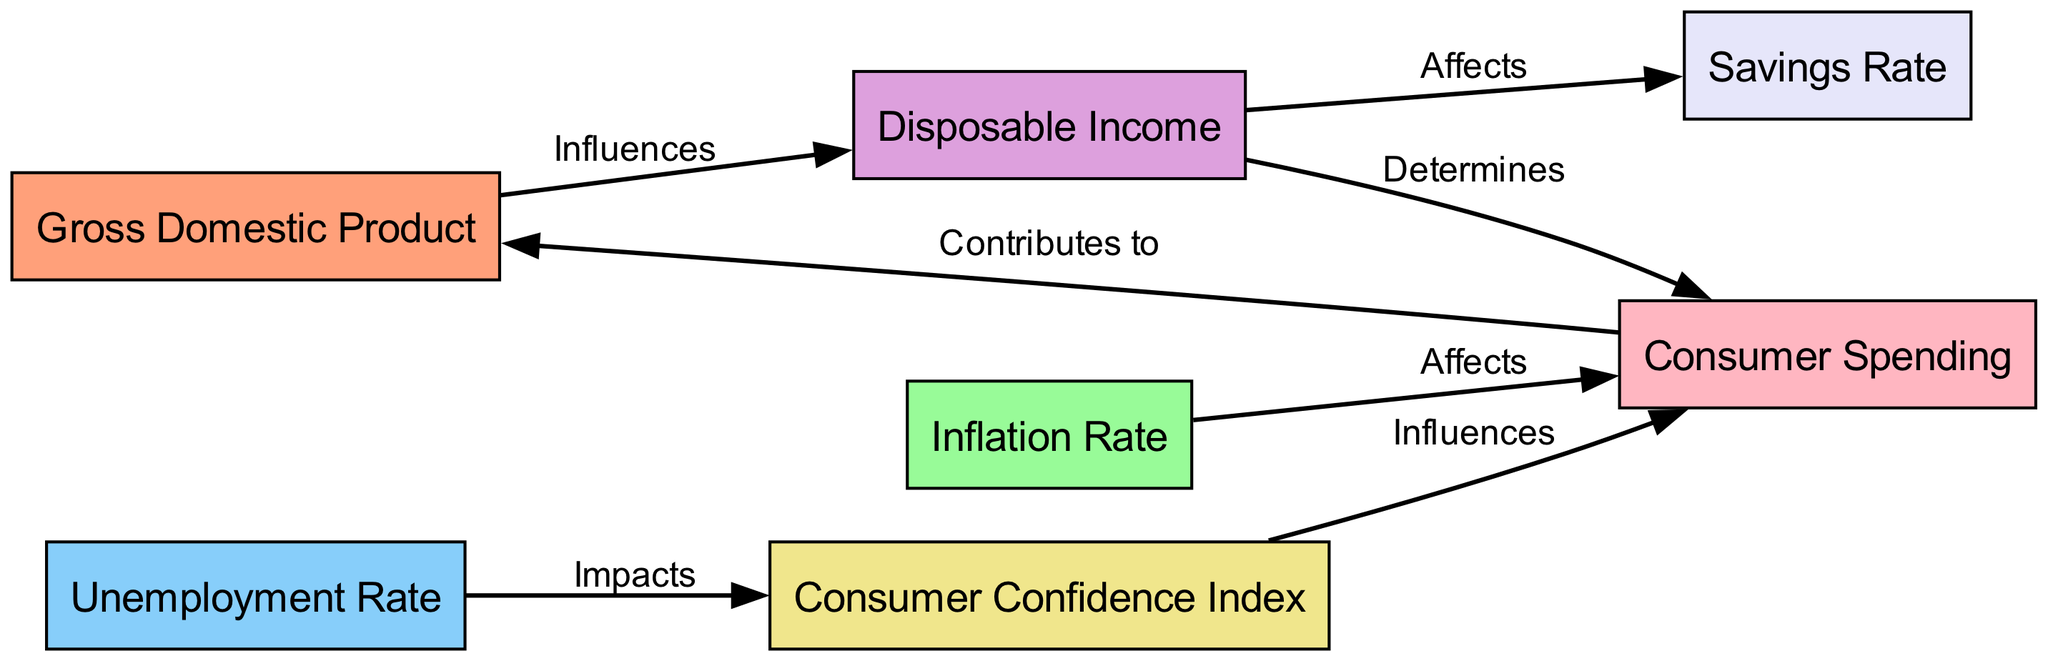What are the nodes represented in the diagram? The nodes in the diagram represent key economic indicators and consumer behavior concepts: Gross Domestic Product, Inflation Rate, Unemployment Rate, Disposable Income, Consumer Confidence Index, Consumer Spending, and Savings Rate.
Answer: Gross Domestic Product, Inflation Rate, Unemployment Rate, Disposable Income, Consumer Confidence Index, Consumer Spending, Savings Rate How many edges are there in total? Counting all the directional connections or edges shown in the diagram, there are a total of 7 edges that illustrate the relationships between the nodes.
Answer: 7 What influences Disposable Income? In the diagram, Disposable Income is influenced by Gross Domestic Product, as indicated by the edge from GDP to Income labeled as "Influences."
Answer: Gross Domestic Product Which factor directly affects Consumer Spending? The diagram indicates that both Disposable Income and Consumer Confidence Index directly affect Consumer Spending, as shown by the edges labeled "Determines" and "Influences," respectively.
Answer: Disposable Income and Consumer Confidence Index What is the relationship between Unemployment Rate and Consumer Confidence Index? The diagram shows that Unemployment Rate impacts Consumer Confidence Index, indicated by the edge labeled "Impacts."
Answer: Impacts Identify the node that contributes to Gross Domestic Product. The diagram shows that Consumer Spending contributes to Gross Domestic Product, as signified by the edge labeled "Contributes to."
Answer: Consumer Spending What is the effect of Inflation Rate on Consumer Spending? According to the diagram, the Inflation Rate affects Consumer Spending, demonstrated by the edge labeled "Affects."
Answer: Affects If Disposable Income increases, what would likely happen to the Savings Rate? The diagram indicates that as Disposable Income affects the Savings Rate, it can be inferred that an increase in Disposable Income would likely lead to an increase in the Savings Rate.
Answer: Increase Which node does not directly impact Gross Domestic Product? In the diagram, the node representing Savings Rate has no direct edge leading to GDP, indicating it does not directly impact Gross Domestic Product compared to the other nodes.
Answer: Savings Rate 